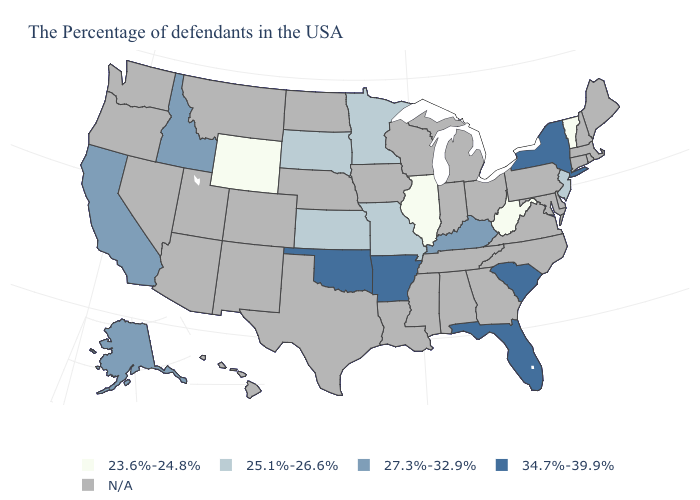Name the states that have a value in the range 23.6%-24.8%?
Give a very brief answer. Vermont, West Virginia, Illinois, Wyoming. What is the value of Utah?
Quick response, please. N/A. What is the value of Mississippi?
Be succinct. N/A. Name the states that have a value in the range N/A?
Quick response, please. Maine, Massachusetts, Rhode Island, New Hampshire, Connecticut, Delaware, Maryland, Pennsylvania, Virginia, North Carolina, Ohio, Georgia, Michigan, Indiana, Alabama, Tennessee, Wisconsin, Mississippi, Louisiana, Iowa, Nebraska, Texas, North Dakota, Colorado, New Mexico, Utah, Montana, Arizona, Nevada, Washington, Oregon, Hawaii. Which states have the highest value in the USA?
Short answer required. New York, South Carolina, Florida, Arkansas, Oklahoma. What is the value of New York?
Short answer required. 34.7%-39.9%. What is the value of Ohio?
Be succinct. N/A. What is the lowest value in the West?
Write a very short answer. 23.6%-24.8%. What is the value of Tennessee?
Short answer required. N/A. What is the lowest value in states that border Oklahoma?
Write a very short answer. 25.1%-26.6%. What is the lowest value in the USA?
Short answer required. 23.6%-24.8%. What is the lowest value in states that border Montana?
Quick response, please. 23.6%-24.8%. Among the states that border Utah , does Wyoming have the highest value?
Concise answer only. No. Which states have the highest value in the USA?
Answer briefly. New York, South Carolina, Florida, Arkansas, Oklahoma. 